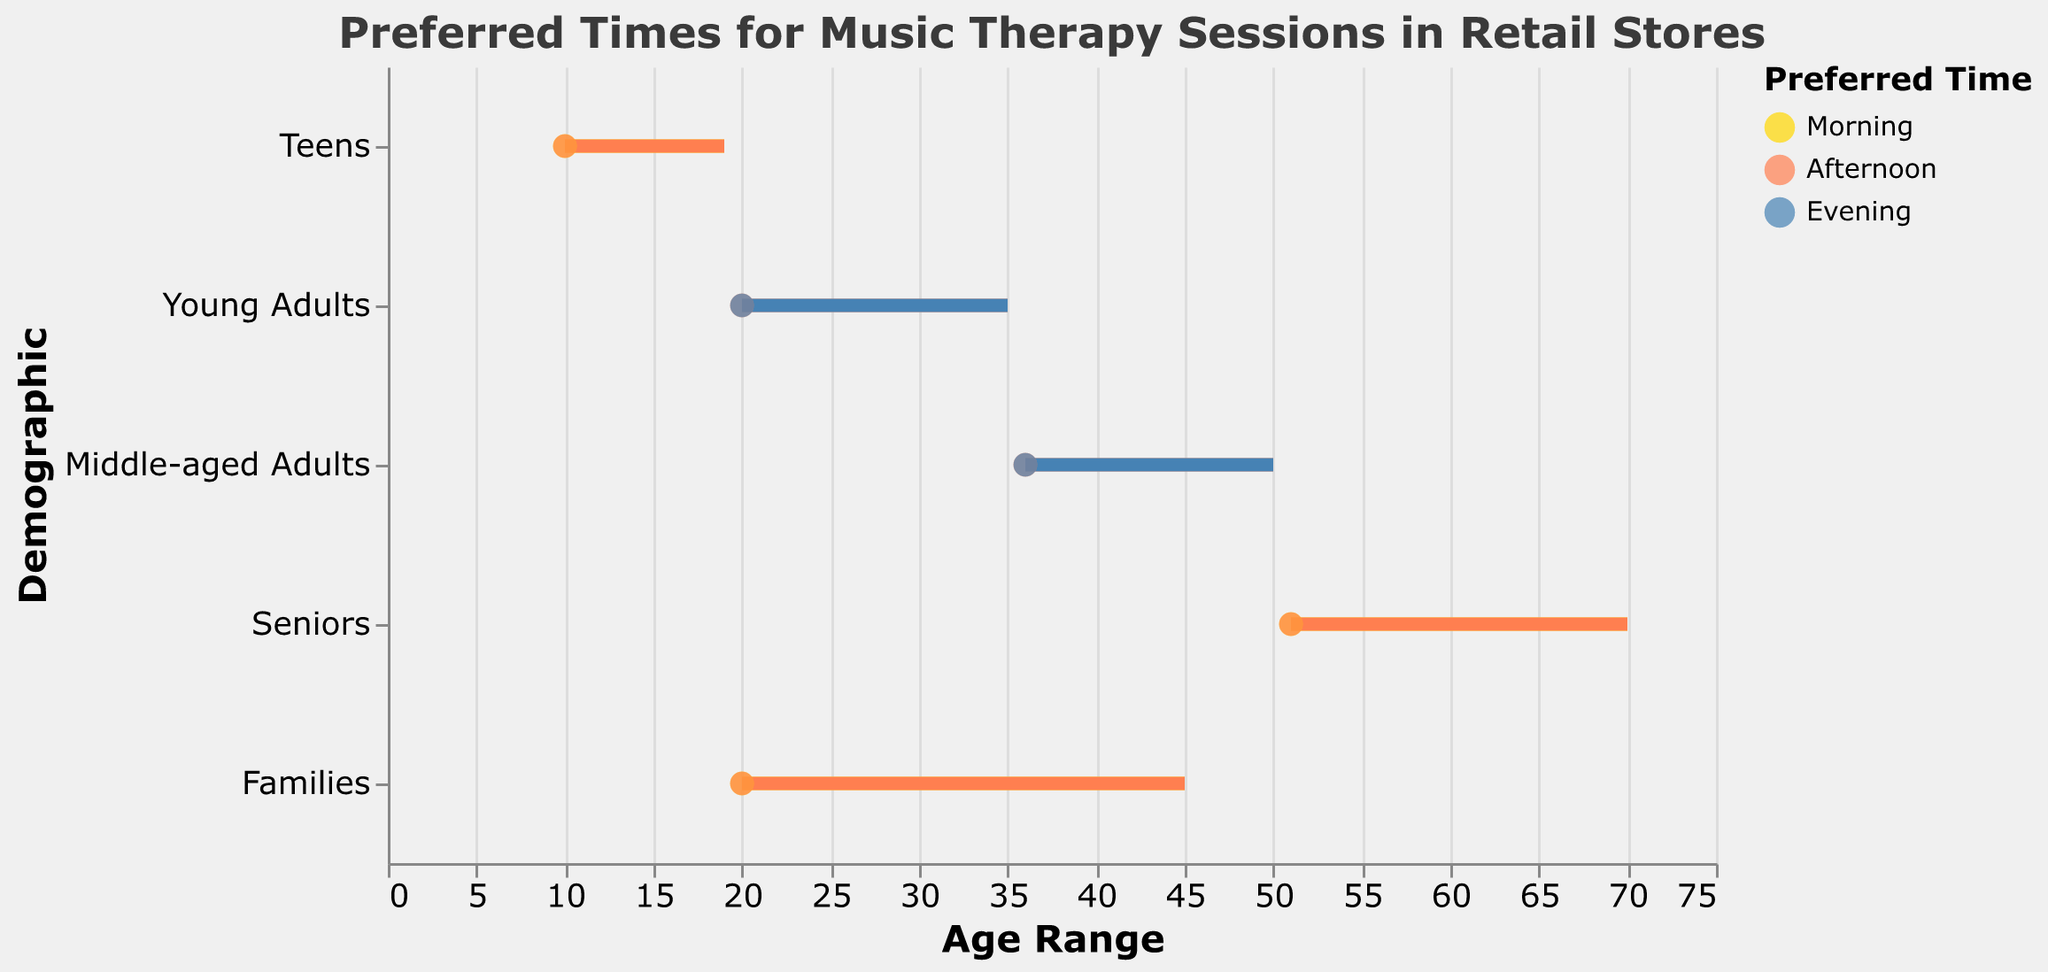How many demographics prefer music therapy sessions in the morning? By observing the colors in the plot, notice the yellow bars which represent 'Morning'. Count all such demographics.
Answer: 3 What is the range of ages for middle-aged adults who prefer music therapy in the afternoon? Look for the demographic "Middle-aged Adults" and the time "Afternoon". Check the length between "Min Age" and "Max Age".
Answer: 36-50 Which demographics prefer music therapy sessions in the evening? Check the blue bars in the plot which represent 'Evening'. Identify the demographics these bars belong to.
Answer: Young Adults, Middle-aged Adults What is the largest age range for the "Families" demographic? For the demographic "Families", compare all age ranges across different times and find the maximum range.
Answer: 20-45 Which preferred time range has the most diverse age group span? Compare the length (age span) of bars for each time range. Identify the time range with the widest span in ages from the youngest age to the oldest age.
Answer: Afternoon How does the preferred time for music therapy sessions vary between teens and seniors? Compare the preferred times mentioned in the figure for "Teens" and "Seniors". Note the differences in preferred session times.
Answer: Teens: Morning, Afternoon; Seniors: Morning, Afternoon Which demographic group has the smallest age range and what is that range? Check the lengths of all bars and identify the shortest one, then find the associated demographic and note the age range.
Answer: Teens, 10-19 For the “Seniors” group, is there a time when they don’t prefer music therapy sessions? For "Seniors", look for the absence of any preferred time slots in the color-coded bars (Morning, Afternoon, Evening).
Answer: Evening How many different time slots (Morning, Afternoon, Evening) are preferred by Young Adults? For the "Young Adults" demographic, count the different times mentioned in the figure.
Answer: 2 What is the minimum age and the maximum age across all demographics for music therapy sessions? Examine all the bars to determine the lowest and highest ages across all demographics and times.
Answer: Min: 10, Max: 70 